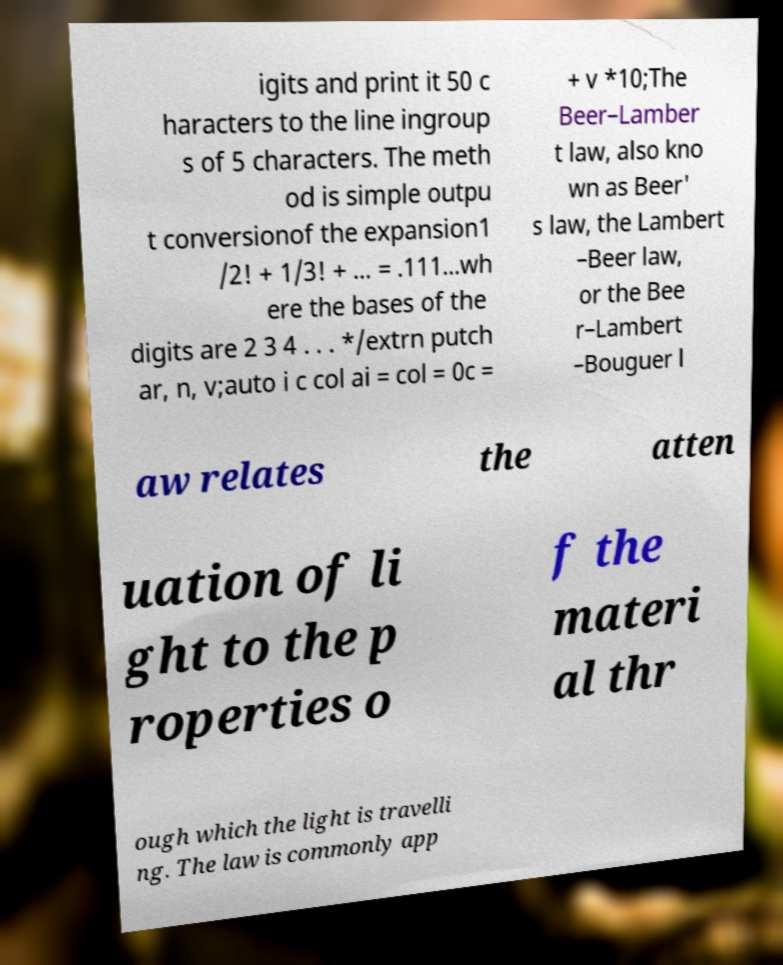Can you read and provide the text displayed in the image?This photo seems to have some interesting text. Can you extract and type it out for me? igits and print it 50 c haracters to the line ingroup s of 5 characters. The meth od is simple outpu t conversionof the expansion1 /2! + 1/3! + ... = .111...wh ere the bases of the digits are 2 3 4 . . . */extrn putch ar, n, v;auto i c col ai = col = 0c = + v *10;The Beer–Lamber t law, also kno wn as Beer' s law, the Lambert –Beer law, or the Bee r–Lambert –Bouguer l aw relates the atten uation of li ght to the p roperties o f the materi al thr ough which the light is travelli ng. The law is commonly app 